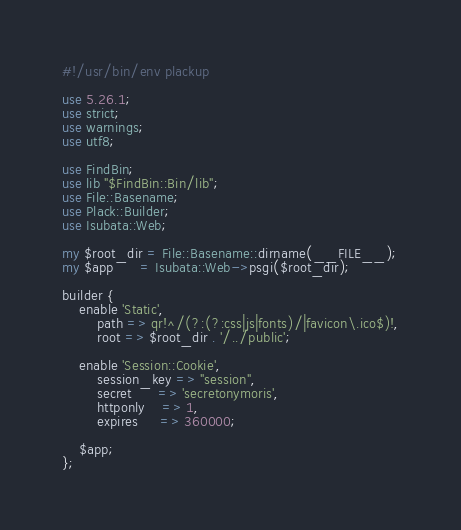<code> <loc_0><loc_0><loc_500><loc_500><_Perl_>#!/usr/bin/env plackup

use 5.26.1;
use strict;
use warnings;
use utf8;

use FindBin;
use lib "$FindBin::Bin/lib";
use File::Basename;
use Plack::Builder;
use Isubata::Web;

my $root_dir = File::Basename::dirname(__FILE__);
my $app      = Isubata::Web->psgi($root_dir);

builder {
    enable 'Static',
        path => qr!^/(?:(?:css|js|fonts)/|favicon\.ico$)!,
        root => $root_dir . '/../public';

    enable 'Session::Cookie',
        session_key => "session",
        secret      => 'secretonymoris',
        httponly    => 1,
        expires     => 360000;

    $app;
};

</code> 